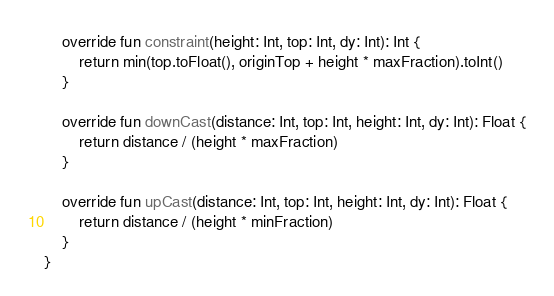Convert code to text. <code><loc_0><loc_0><loc_500><loc_500><_Kotlin_>    override fun constraint(height: Int, top: Int, dy: Int): Int {
        return min(top.toFloat(), originTop + height * maxFraction).toInt()
    }

    override fun downCast(distance: Int, top: Int, height: Int, dy: Int): Float {
        return distance / (height * maxFraction)
    }

    override fun upCast(distance: Int, top: Int, height: Int, dy: Int): Float {
        return distance / (height * minFraction)
    }
}</code> 